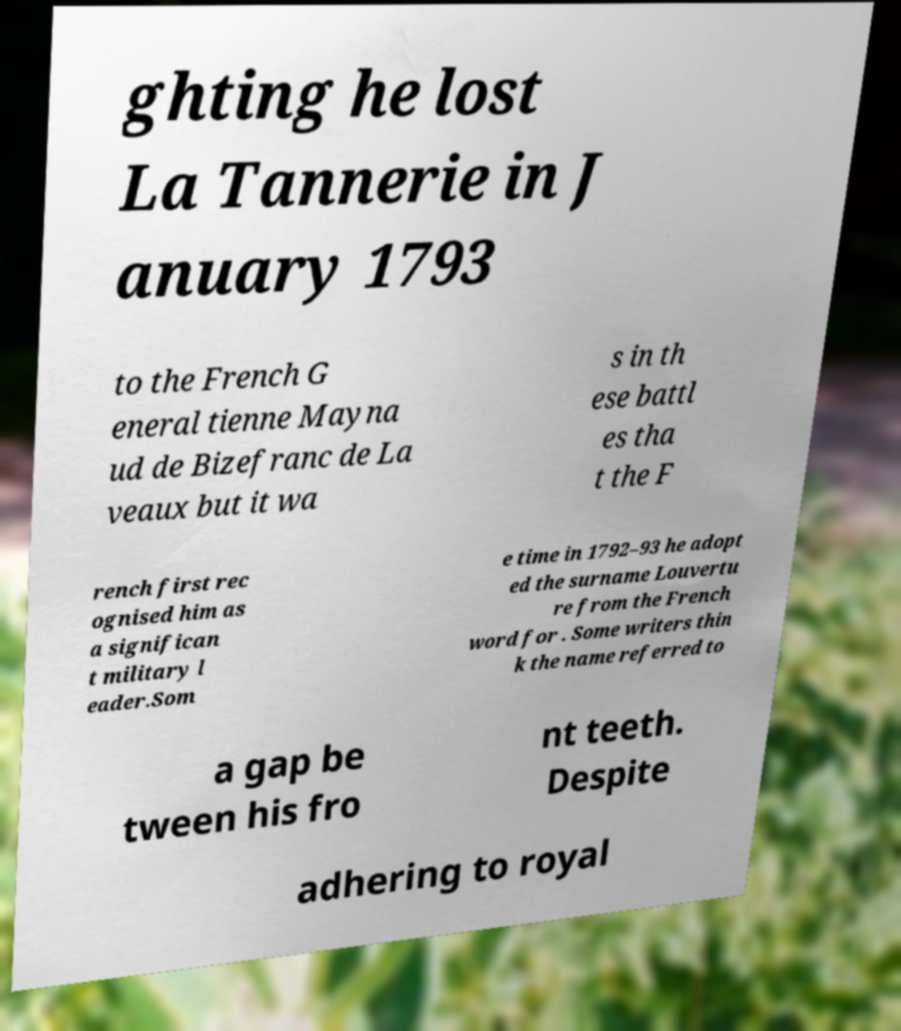Can you accurately transcribe the text from the provided image for me? ghting he lost La Tannerie in J anuary 1793 to the French G eneral tienne Mayna ud de Bizefranc de La veaux but it wa s in th ese battl es tha t the F rench first rec ognised him as a significan t military l eader.Som e time in 1792–93 he adopt ed the surname Louvertu re from the French word for . Some writers thin k the name referred to a gap be tween his fro nt teeth. Despite adhering to royal 